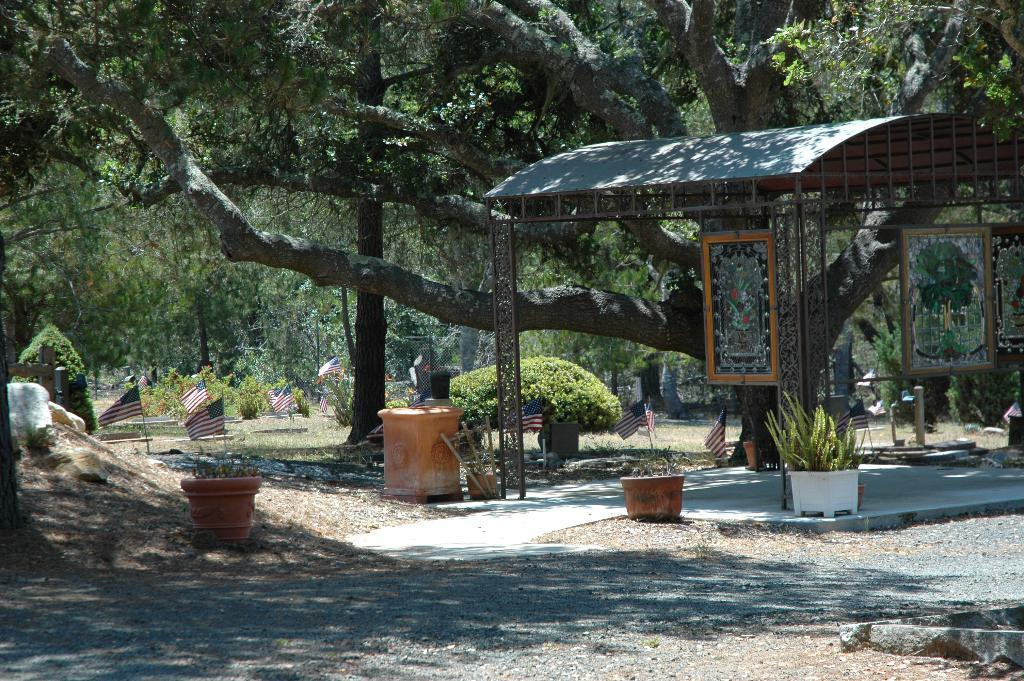What structure is located on the right side of the image? There is a shed on the right side of the image. What objects can be seen at the bottom of the image? There are flower pots at the bottom of the image. What type of vegetation is in the background of the image? There are bushes and trees in the background of the image. What additional features can be seen in the background of the image? There are flags in the background of the image. What type of education is being provided to the geese in the image? There are no geese present in the image, so no education is being provided to them. Can you tell me how many horses are visible in the image? There are no horses present in the image. 